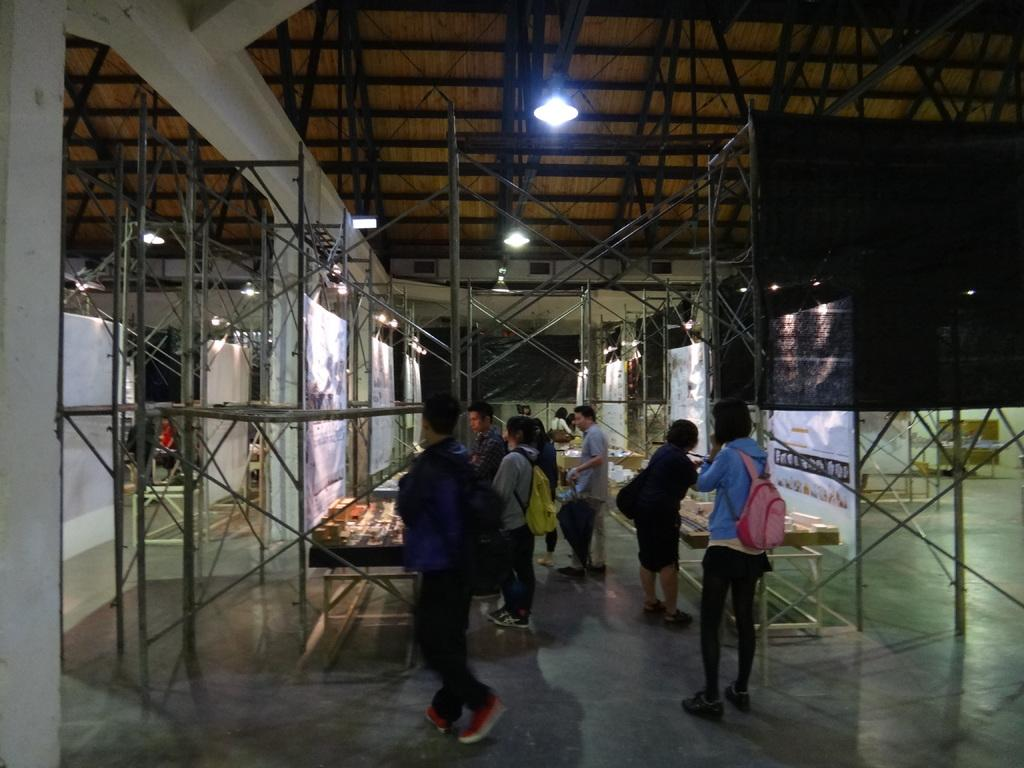Where was the image taken? The image was taken inside a shelter. What are the people in the image doing? There are persons walking and standing in the shelter. What can be seen on the tables in the shelter? There are objects on the tables in the shelter. What type of structural elements are present in the shelter? There are rods in the shelter. What provides illumination in the shelter? There are lights in the shelter. What is hanging from the ceiling in the shelter? There is a banner in the shelter. What part of the shelter's structure is visible at the top? The inside roof of the shelter is visible at the top. What type of light is being used by the representative of the club in the image? There is no representative of a club present in the image, nor is there any light being used by anyone in the image. 